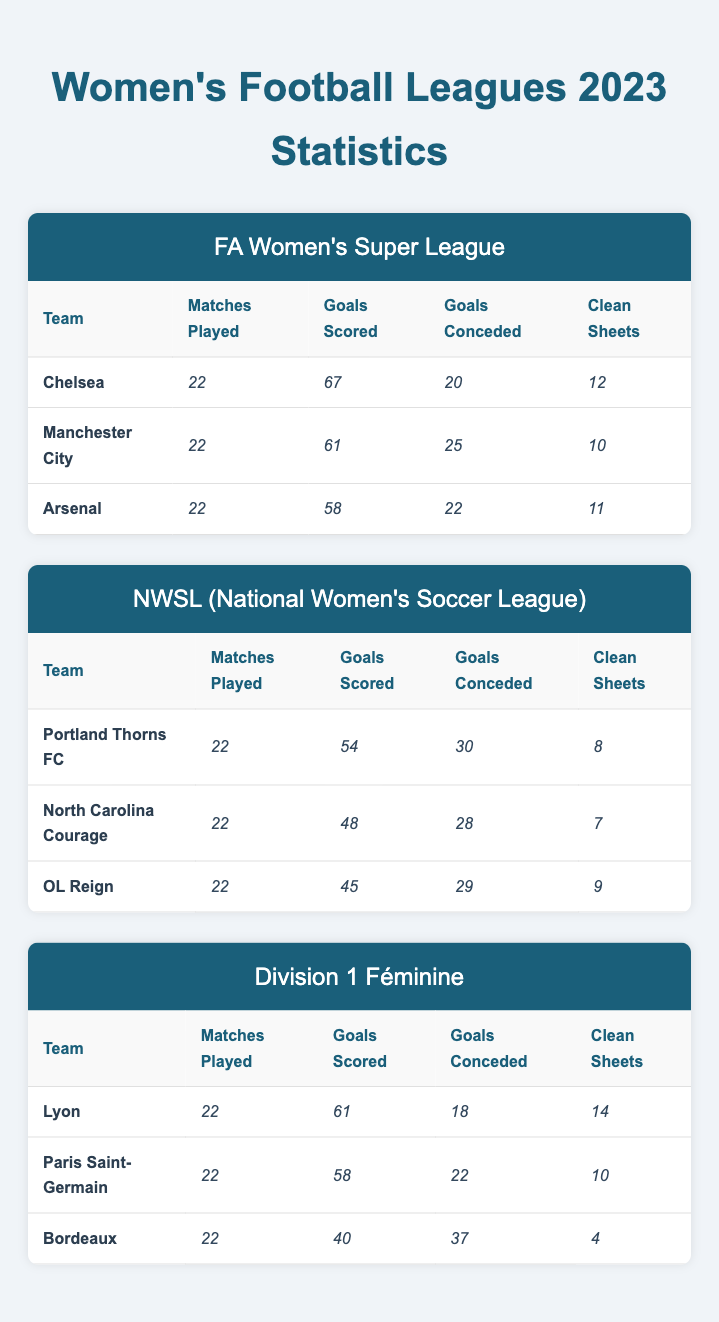What team has the most clean sheets in the FA Women's Super League? According to the table, Chelsea has the highest number of clean sheets at 12 compared to Manchester City with 10 and Arsenal with 11.
Answer: Chelsea What is the goal difference for Lyon? To find Lyon's goal difference, subtract the goals conceded from the goals scored: 61 (goals scored) - 18 (goals conceded) = 43.
Answer: 43 Which league has the team with the highest goals scored? In the FA Women's Super League, Chelsea scored 67 goals, which is the highest among all the teams listed in the table across leagues.
Answer: FA Women's Super League Which team has the lowest goals conceded in the NWSL? The table shows that North Carolina Courage has conceded 28 goals, which is lower than Portland Thorns FC (30) and OL Reign (29).
Answer: North Carolina Courage What is the average number of clean sheets for teams in Division 1 Féminine? To find the average, sum the clean sheets (14 + 10 + 4 = 28) and divide by the number of teams (3): 28 / 3 = 9.33.
Answer: 9.33 Is it true that all teams in the NWSL have more goals scored than goals conceded? Checking the goals scored and conceded for each NWSL team, we find that Portland Thorns (54/30), North Carolina Courage (48/28), and OL Reign (45/29) all scored more than they conceded, so the statement is true.
Answer: Yes Which league has the lowest average number of goals conceded per team? For the leagues: FA Women's Super League (22.5), NWSL (29), and Division 1 Féminine (26.67), the FA Women's Super League has the lowest average goals conceded per team.
Answer: FA Women's Super League What is the total number of goals scored by Arsenal and Manchester City combined? To find the total, add the goals scored by Arsenal (58) and Manchester City (61): 58 + 61 = 119.
Answer: 119 Which team in the Division 1 Féminine has the worst clean sheet record? Bordeaux has the lowest number of clean sheets with just 4, compared to Lyon (14) and Paris Saint-Germain (10).
Answer: Bordeaux What is the overall clean sheet ratio for the FA Women's Super League? For clean sheets in the league, the total is (12 + 10 + 11 = 33) with matches played (22 per team x 3 teams = 66). Clean sheets ratio = 33 / 66 = 0.50 or 50%.
Answer: 50% 